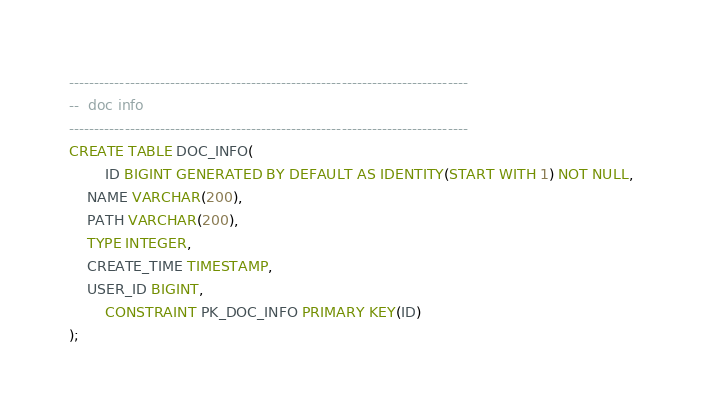<code> <loc_0><loc_0><loc_500><loc_500><_SQL_>

-------------------------------------------------------------------------------
--  doc info
-------------------------------------------------------------------------------
CREATE TABLE DOC_INFO(
        ID BIGINT GENERATED BY DEFAULT AS IDENTITY(START WITH 1) NOT NULL,
	NAME VARCHAR(200),
	PATH VARCHAR(200),
	TYPE INTEGER,
	CREATE_TIME TIMESTAMP,
	USER_ID BIGINT,
        CONSTRAINT PK_DOC_INFO PRIMARY KEY(ID)
);

</code> 